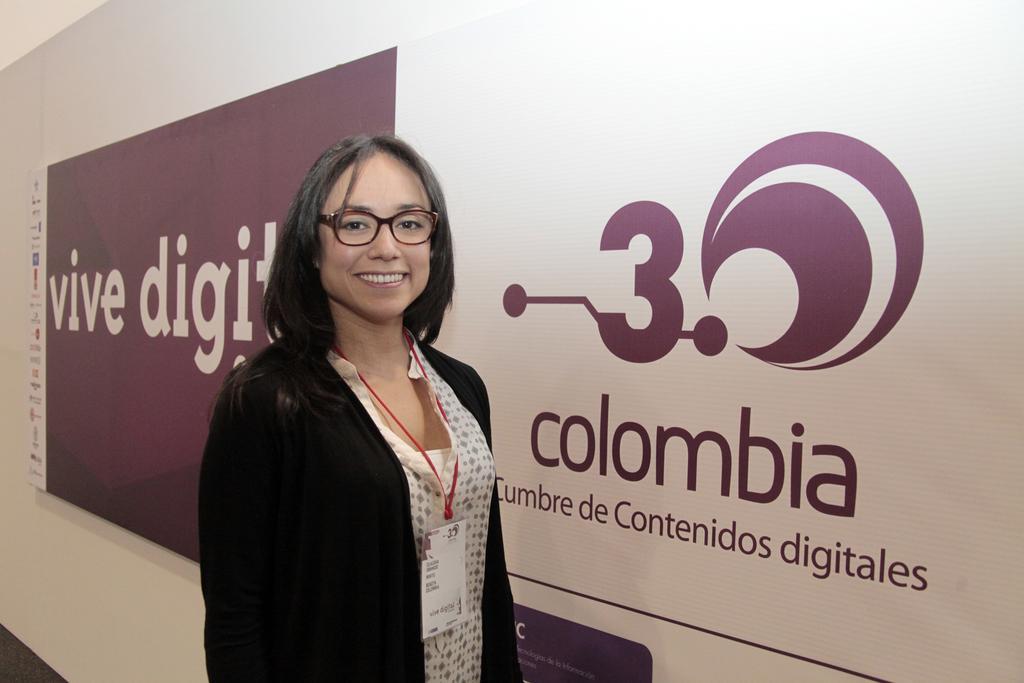Please provide a concise description of this image. In this image we can see a woman standing. On the backside we can see a banner with some text on it. 